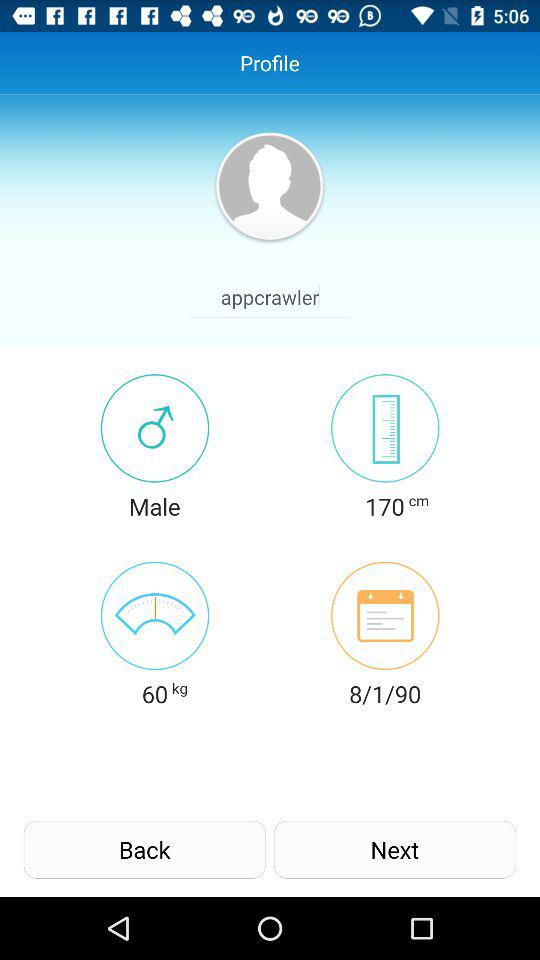What is the gender? The gender is male. 